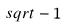Convert formula to latex. <formula><loc_0><loc_0><loc_500><loc_500>s q r t - 1</formula> 